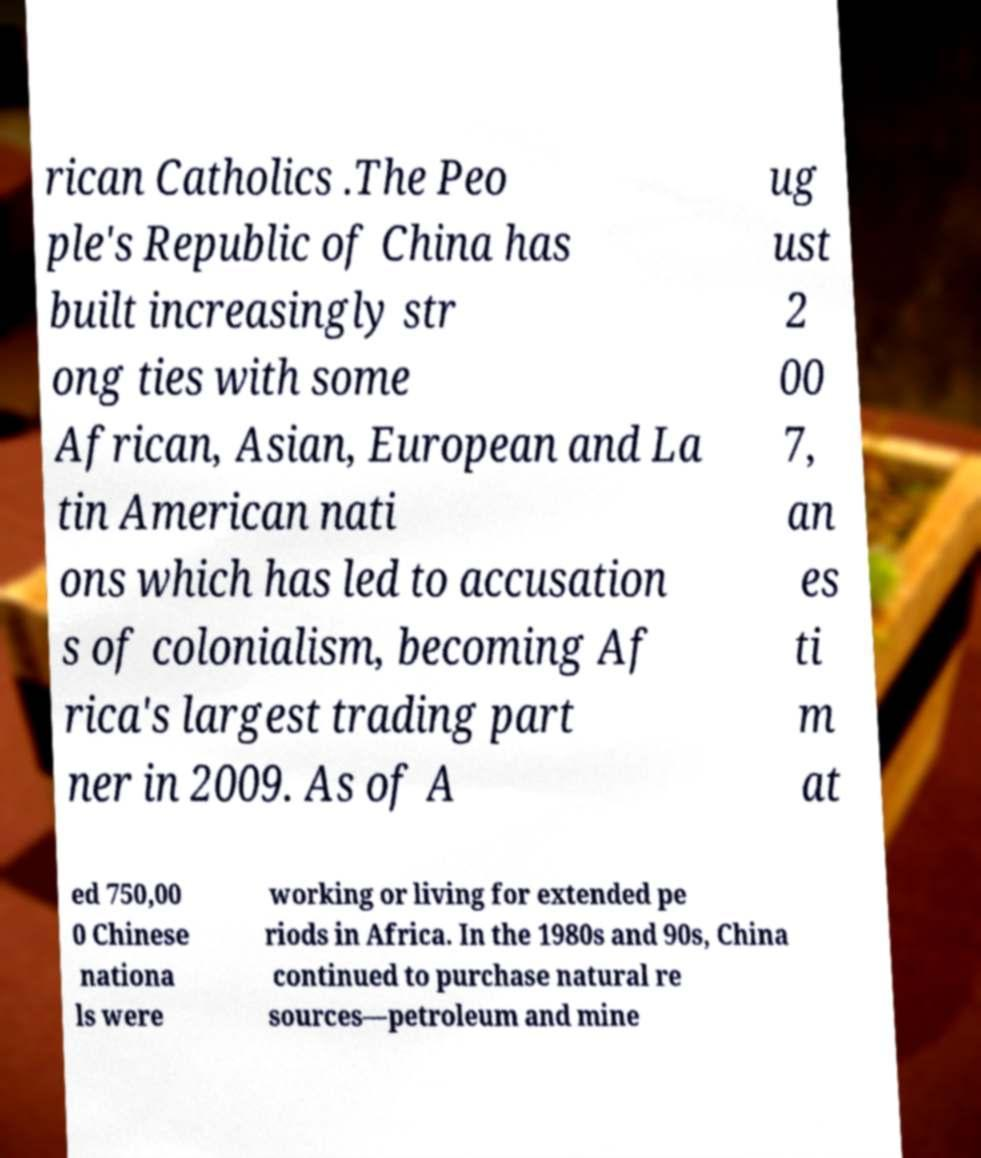There's text embedded in this image that I need extracted. Can you transcribe it verbatim? rican Catholics .The Peo ple's Republic of China has built increasingly str ong ties with some African, Asian, European and La tin American nati ons which has led to accusation s of colonialism, becoming Af rica's largest trading part ner in 2009. As of A ug ust 2 00 7, an es ti m at ed 750,00 0 Chinese nationa ls were working or living for extended pe riods in Africa. In the 1980s and 90s, China continued to purchase natural re sources—petroleum and mine 